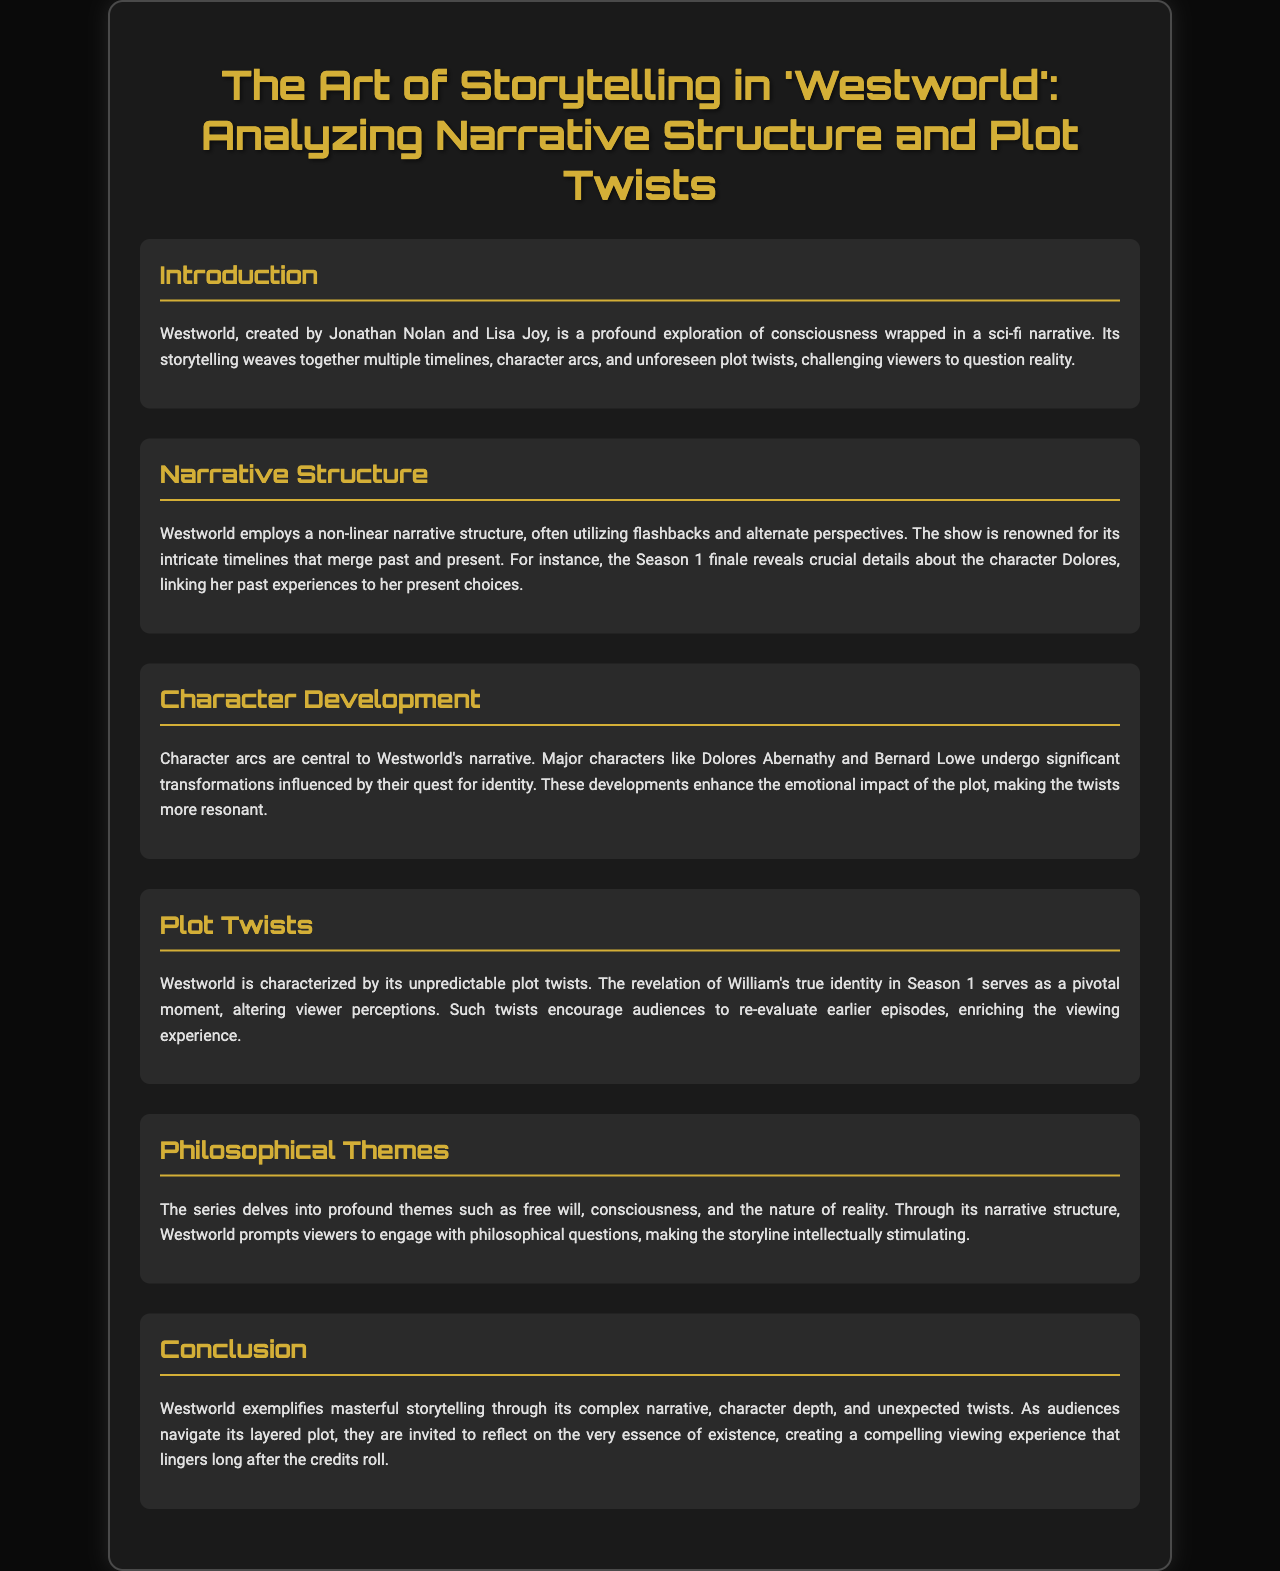What is the title of the brochure? The title of the brochure is stated at the top of the document.
Answer: The Art of Storytelling in 'Westworld': Analyzing Narrative Structure and Plot Twists Who are the creators of Westworld? The creators of Westworld are mentioned in the introduction section of the document.
Answer: Jonathan Nolan and Lisa Joy What significant reveal occurs in the Season 1 finale? The document discusses a crucial detail regarding the character Dolores revealed in the Season 1 finale.
Answer: Dolores' past experiences What is a central theme explored in Westworld? The brochure highlights profound themes explored in the series such as free will, consciousness, and reality.
Answer: Free will Who undergoes significant transformations in the narrative? Character development is discussed, particularly mentioning major characters that change throughout the series.
Answer: Dolores Abernathy and Bernard Lowe What type of narrative structure does Westworld employ? The document describes the show's narrative structure characterized by its style.
Answer: Non-linear What is a pivotal moment in Season 1? The document mentions a specific plot twist involving a character that affects viewer perceptions.
Answer: William's true identity How does the series affect viewer perceptions? The document suggests a specific way the series engages viewers with its storytelling techniques.
Answer: Encourages re-evaluation What kind of questions does the series prompt viewers to engage with? The document mentions the type of philosophical engagement the series invites from its audience.
Answer: Philosophical questions 